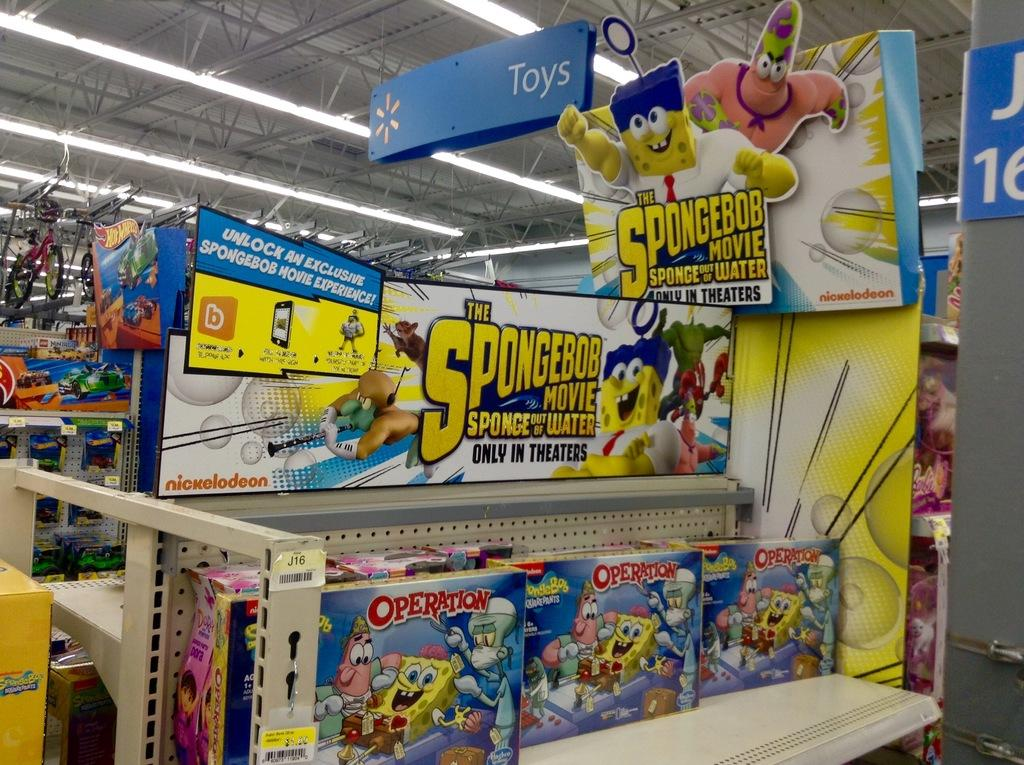<image>
Render a clear and concise summary of the photo. many spongebob operation games are on a shelf in walmart 